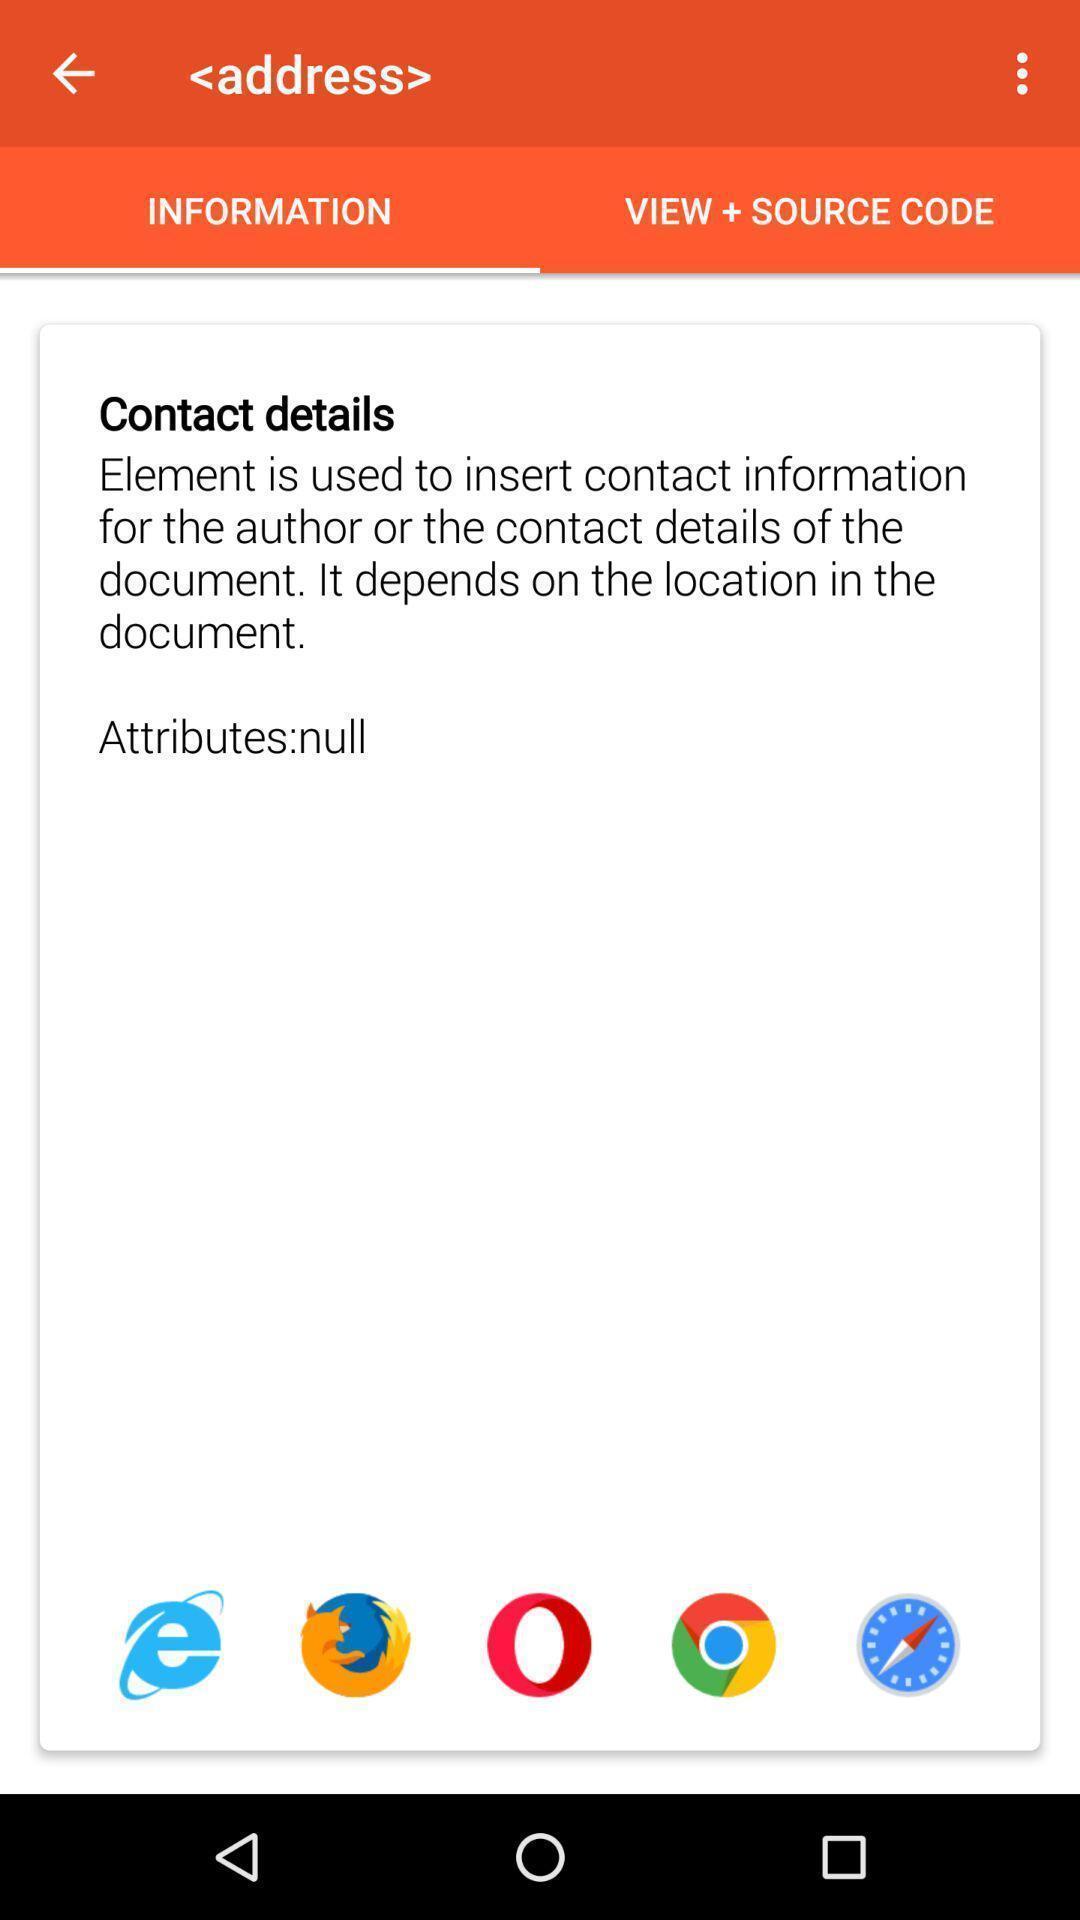Describe the content in this image. Screen shows information details. 